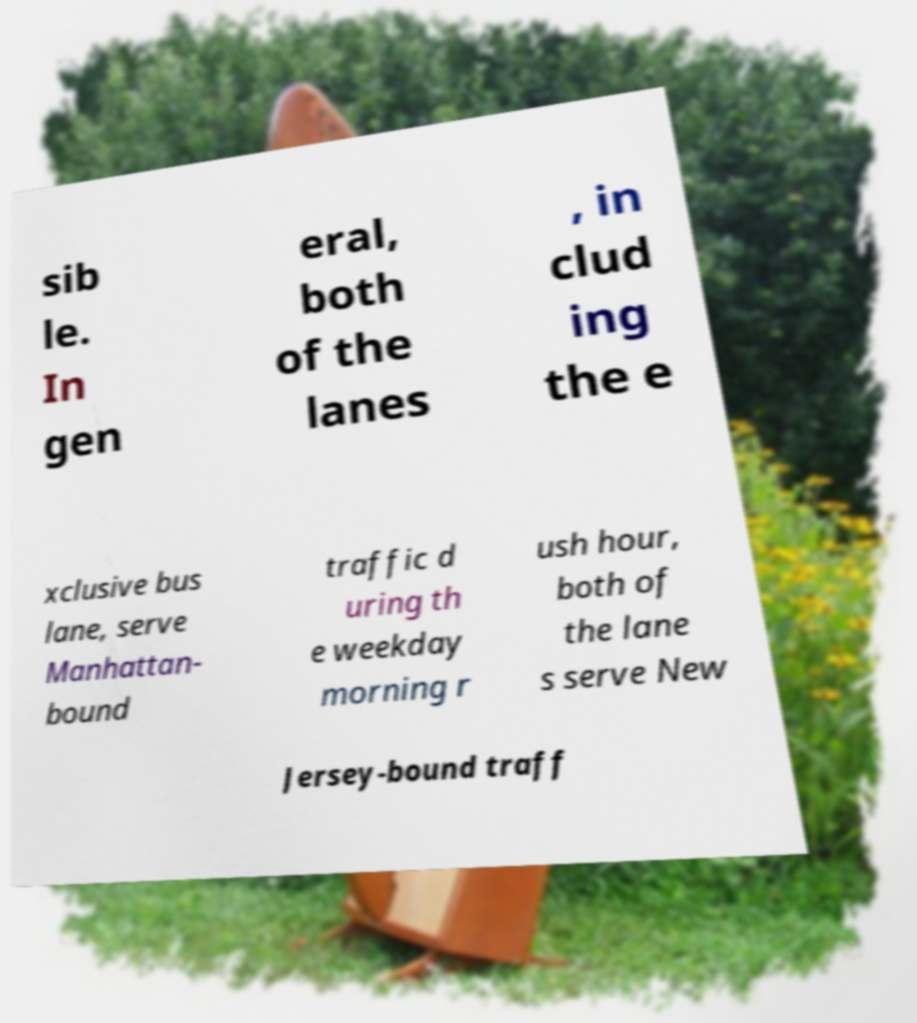Could you assist in decoding the text presented in this image and type it out clearly? sib le. In gen eral, both of the lanes , in clud ing the e xclusive bus lane, serve Manhattan- bound traffic d uring th e weekday morning r ush hour, both of the lane s serve New Jersey-bound traff 